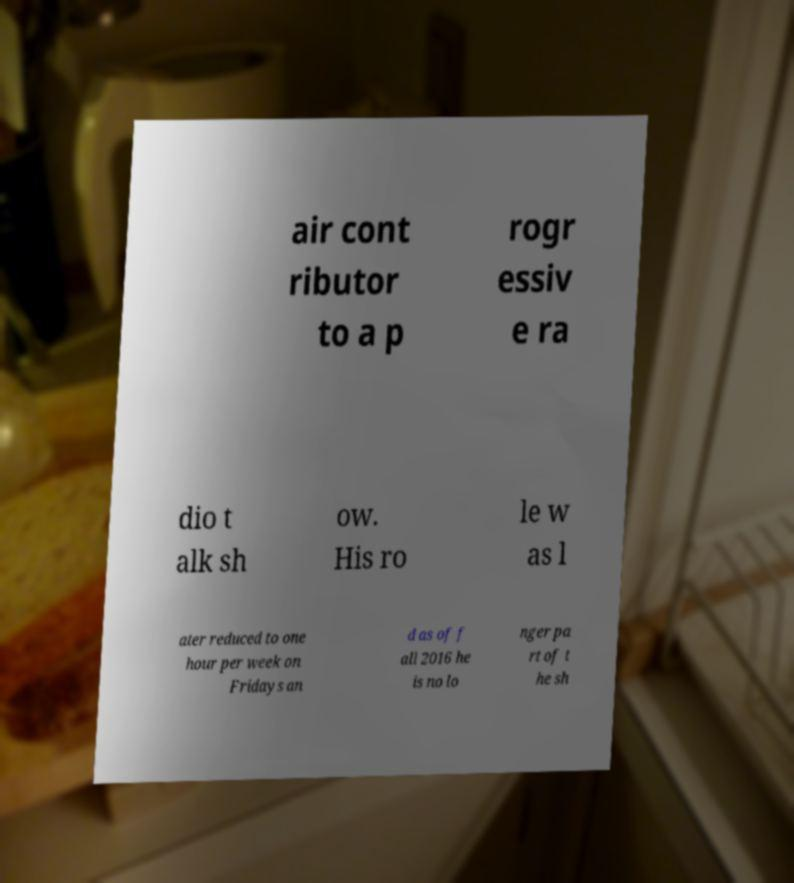Could you extract and type out the text from this image? air cont ributor to a p rogr essiv e ra dio t alk sh ow. His ro le w as l ater reduced to one hour per week on Fridays an d as of f all 2016 he is no lo nger pa rt of t he sh 